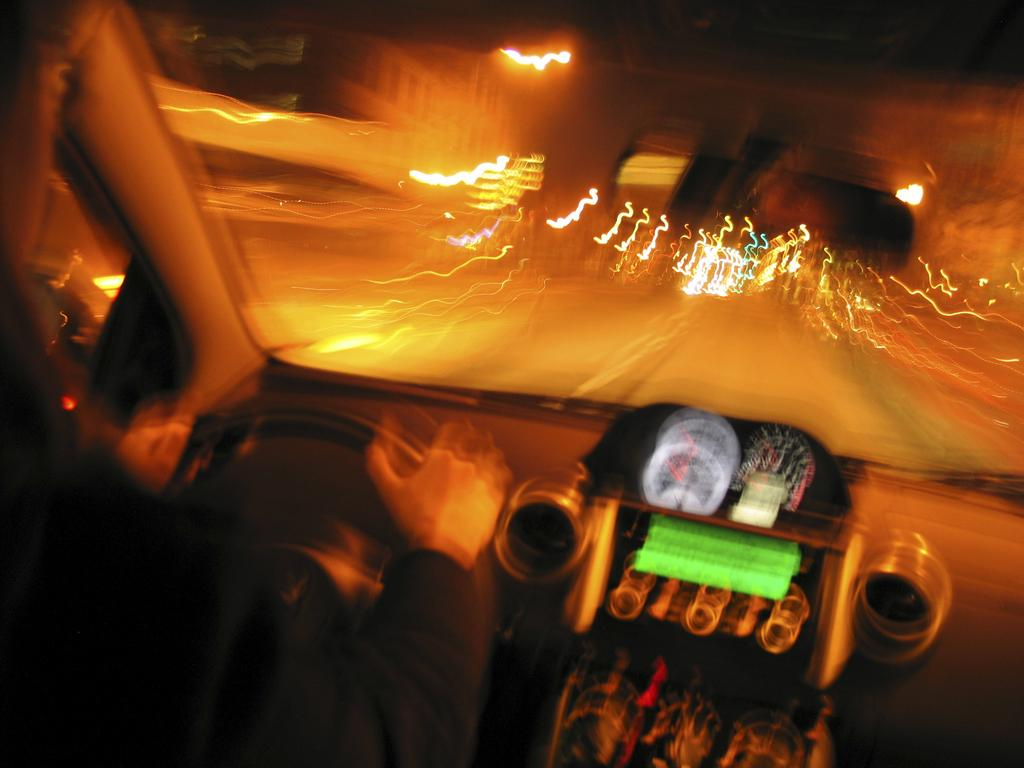What is the person in the image doing? There is a person sitting inside a car in the image. What is in front of the person? There is a glass in front of the person. What can be seen through the glass? Lights, the road, and buildings are visible through the glass. What type of hat is the person wearing in the image? There is no hat visible in the image; the person is sitting inside a car with a glass in front of them. What color is the ink used to write on the buildings in the image? There is no indication of writing or ink on the buildings in the image; they are simply visible through the glass. 